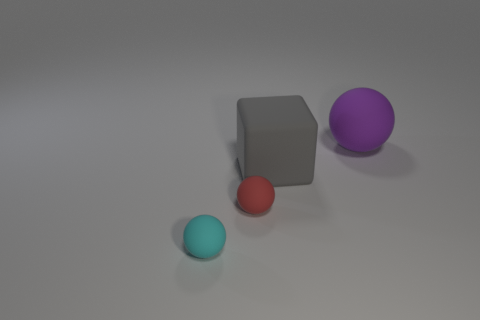What is the shape of the small object that is behind the tiny cyan object in front of the large thing left of the big purple rubber sphere?
Give a very brief answer. Sphere. Are there fewer tiny red spheres than small red metal cylinders?
Ensure brevity in your answer.  No. Are there any tiny objects left of the tiny cyan object?
Offer a terse response. No. There is a rubber thing that is both right of the tiny cyan ball and on the left side of the big gray rubber block; what is its shape?
Offer a terse response. Sphere. Is there a tiny gray matte thing that has the same shape as the big gray object?
Your response must be concise. No. There is a sphere right of the big cube; is its size the same as the gray cube that is to the right of the cyan ball?
Give a very brief answer. Yes. Is the number of big brown matte cubes greater than the number of objects?
Give a very brief answer. No. How many big cylinders have the same material as the small red ball?
Keep it short and to the point. 0. Does the purple object have the same shape as the tiny cyan matte object?
Your answer should be very brief. Yes. How big is the matte ball that is behind the big rubber object that is in front of the thing behind the rubber cube?
Your answer should be very brief. Large. 